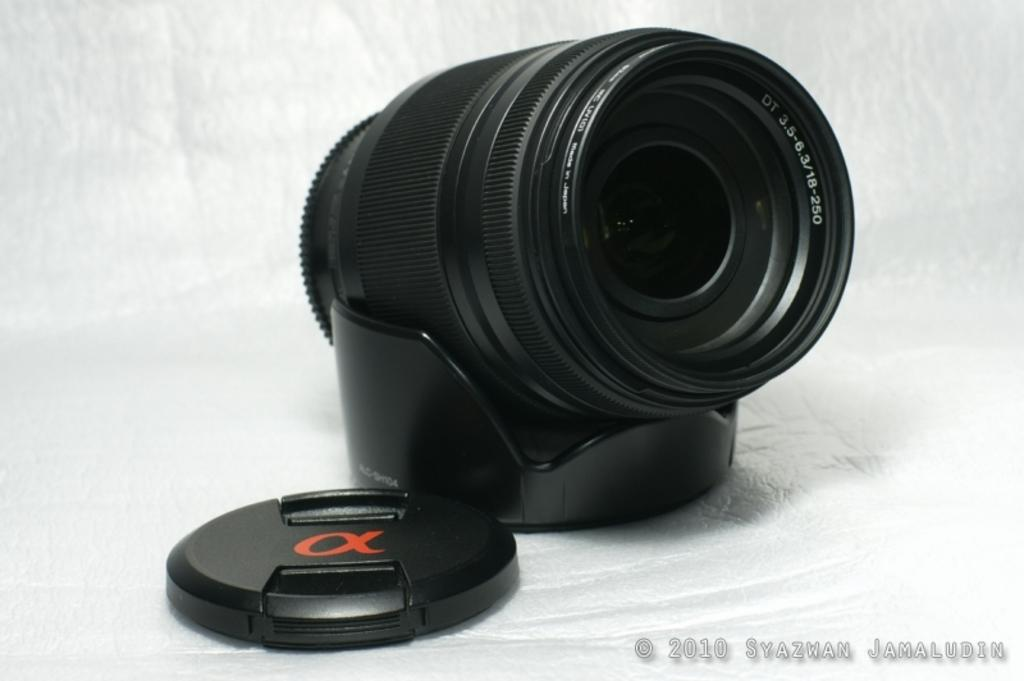<image>
Create a compact narrative representing the image presented. A black camera lens that was made in Japan 